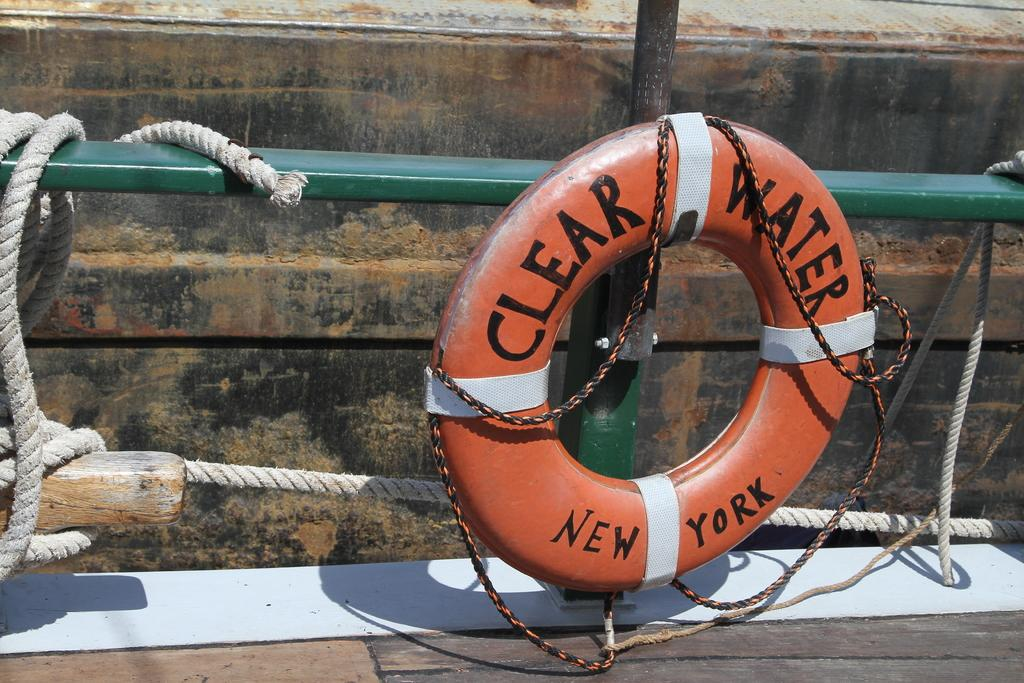What is the main object in the image? There is a tube with belts and wire in the image. What other items can be seen in the image? There are ropes and rods in the image. What type of material is the wooden object made of? There is a wooden object in the image. Can you see any wounds on the belts in the image? There is no indication of any wounds on the belts in the image. What type of bird feather is present in the image? There is no bird feather, specifically a quill, present in the image. 